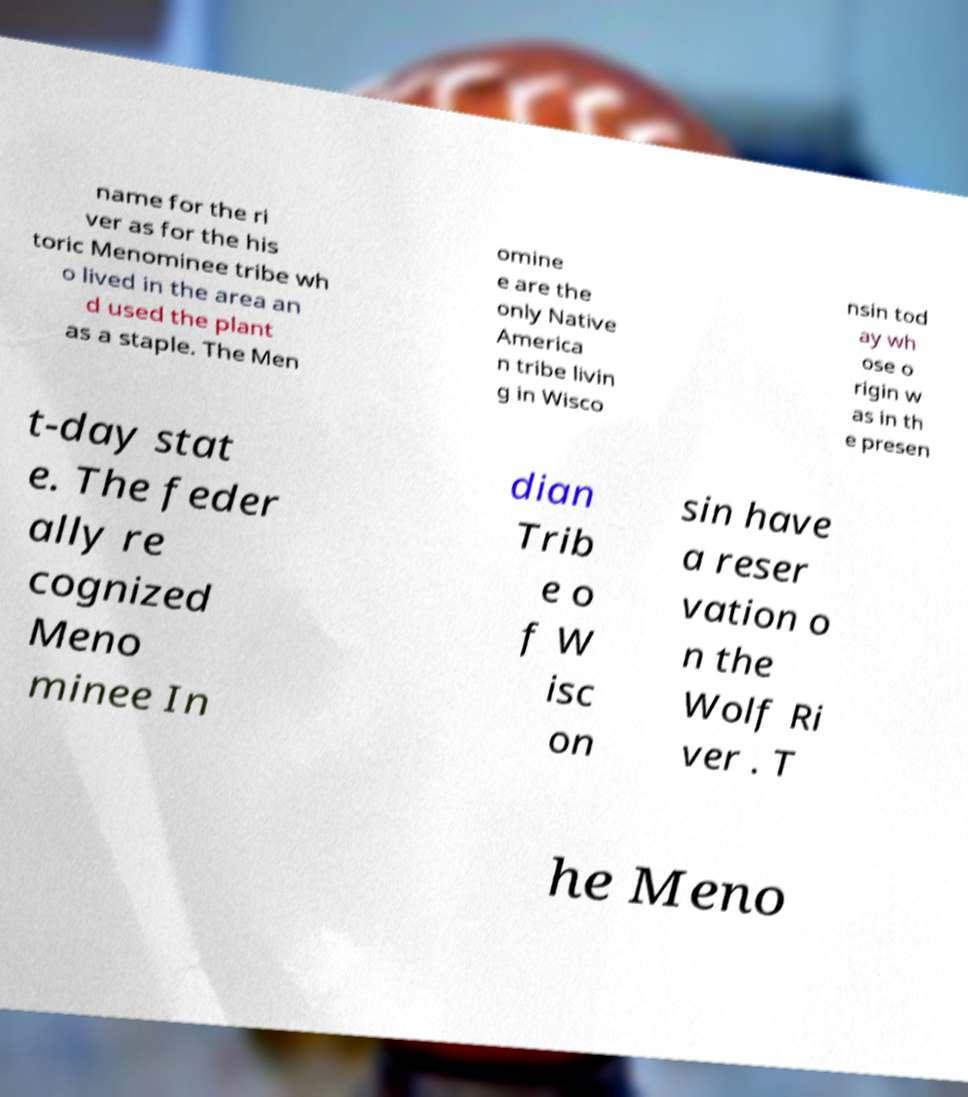Could you assist in decoding the text presented in this image and type it out clearly? name for the ri ver as for the his toric Menominee tribe wh o lived in the area an d used the plant as a staple. The Men omine e are the only Native America n tribe livin g in Wisco nsin tod ay wh ose o rigin w as in th e presen t-day stat e. The feder ally re cognized Meno minee In dian Trib e o f W isc on sin have a reser vation o n the Wolf Ri ver . T he Meno 